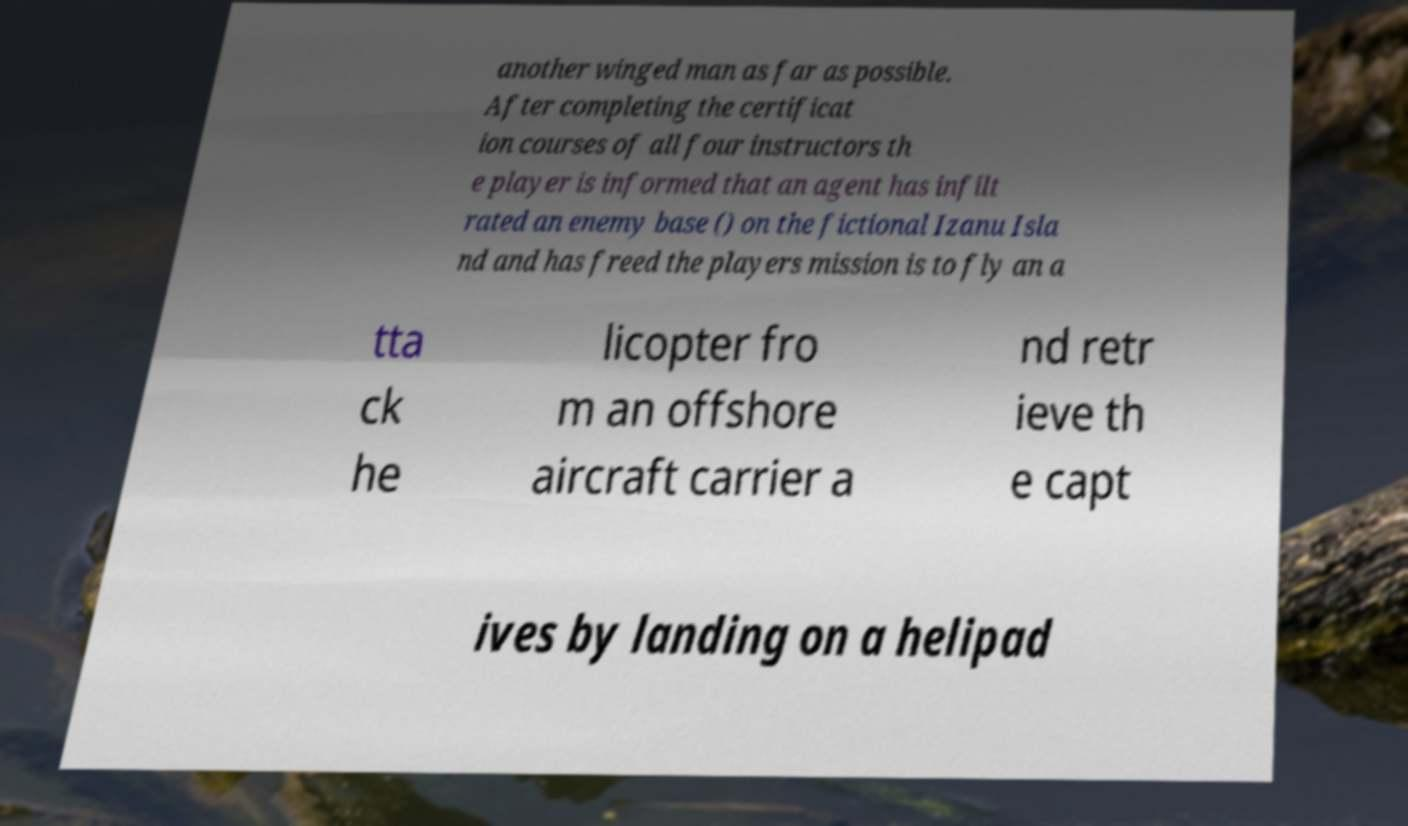Could you assist in decoding the text presented in this image and type it out clearly? another winged man as far as possible. After completing the certificat ion courses of all four instructors th e player is informed that an agent has infilt rated an enemy base () on the fictional Izanu Isla nd and has freed the players mission is to fly an a tta ck he licopter fro m an offshore aircraft carrier a nd retr ieve th e capt ives by landing on a helipad 